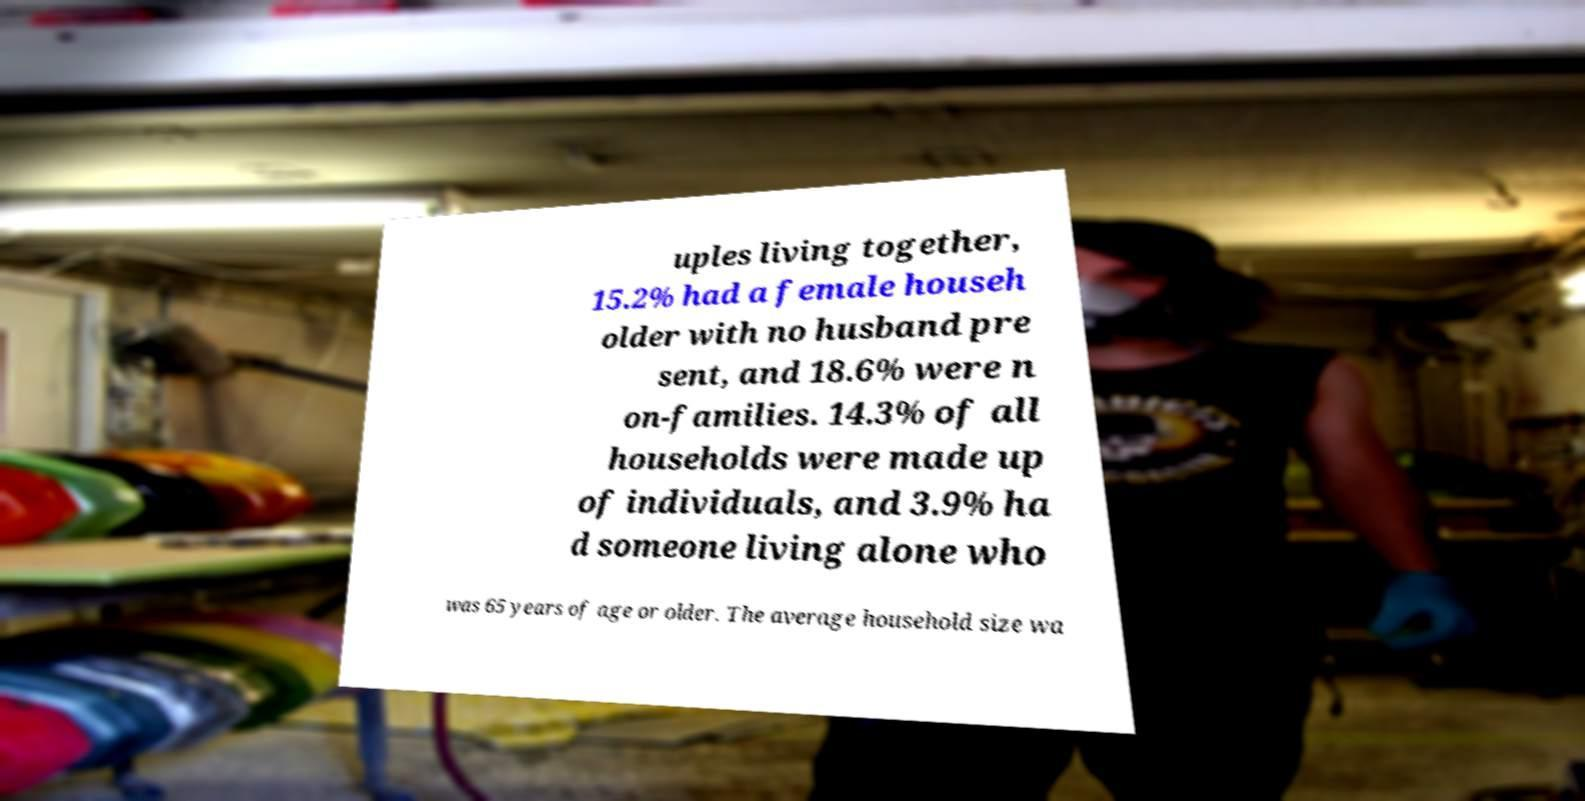Can you read and provide the text displayed in the image?This photo seems to have some interesting text. Can you extract and type it out for me? uples living together, 15.2% had a female househ older with no husband pre sent, and 18.6% were n on-families. 14.3% of all households were made up of individuals, and 3.9% ha d someone living alone who was 65 years of age or older. The average household size wa 